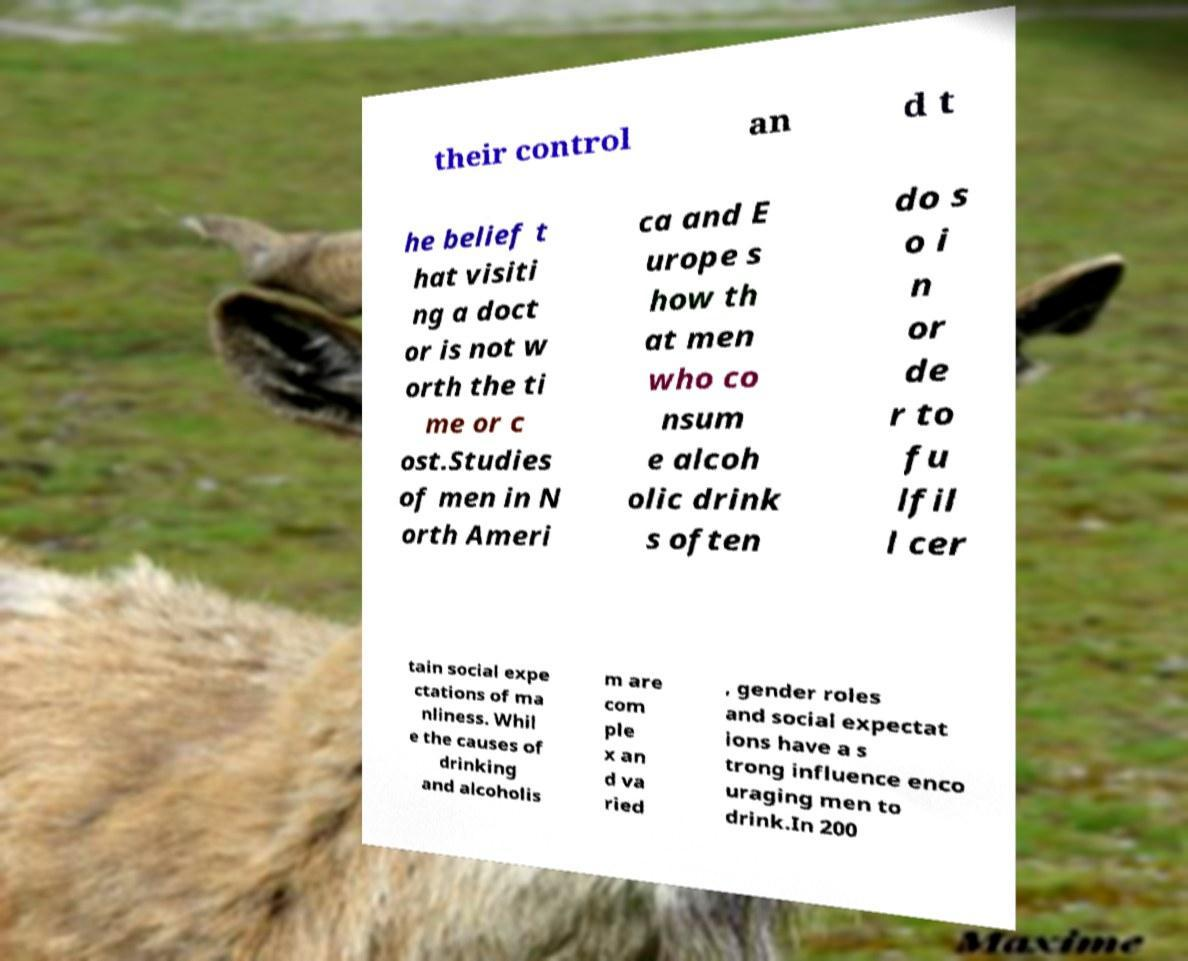Could you extract and type out the text from this image? their control an d t he belief t hat visiti ng a doct or is not w orth the ti me or c ost.Studies of men in N orth Ameri ca and E urope s how th at men who co nsum e alcoh olic drink s often do s o i n or de r to fu lfil l cer tain social expe ctations of ma nliness. Whil e the causes of drinking and alcoholis m are com ple x an d va ried , gender roles and social expectat ions have a s trong influence enco uraging men to drink.In 200 